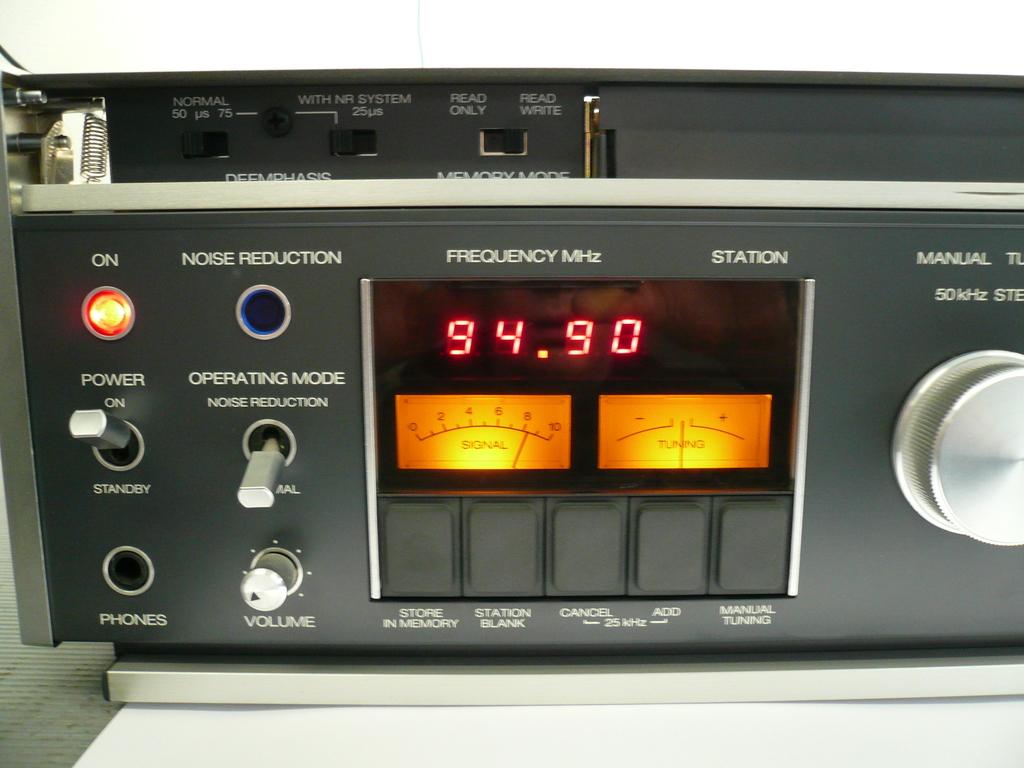What frequency is this tuned to?
Keep it short and to the point. 94.90. 